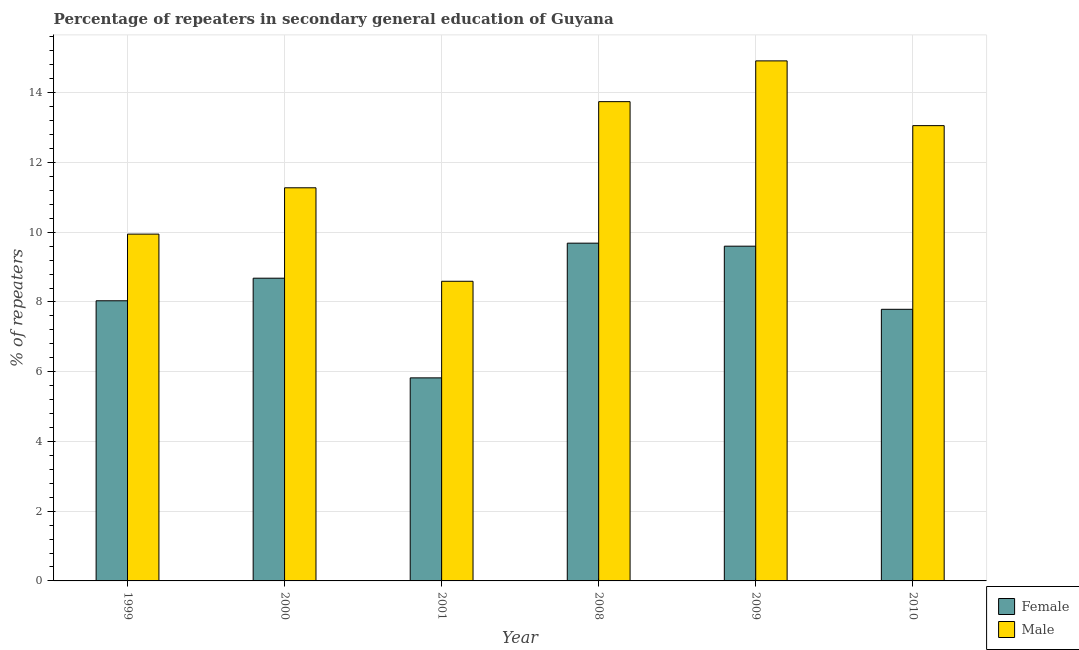How many different coloured bars are there?
Keep it short and to the point. 2. Are the number of bars on each tick of the X-axis equal?
Provide a short and direct response. Yes. How many bars are there on the 1st tick from the left?
Make the answer very short. 2. What is the label of the 2nd group of bars from the left?
Offer a terse response. 2000. In how many cases, is the number of bars for a given year not equal to the number of legend labels?
Make the answer very short. 0. What is the percentage of male repeaters in 1999?
Ensure brevity in your answer.  9.95. Across all years, what is the maximum percentage of male repeaters?
Offer a terse response. 14.91. Across all years, what is the minimum percentage of female repeaters?
Your answer should be very brief. 5.82. In which year was the percentage of male repeaters maximum?
Your answer should be compact. 2009. In which year was the percentage of male repeaters minimum?
Keep it short and to the point. 2001. What is the total percentage of female repeaters in the graph?
Your response must be concise. 49.61. What is the difference between the percentage of male repeaters in 1999 and that in 2009?
Offer a terse response. -4.97. What is the difference between the percentage of male repeaters in 2009 and the percentage of female repeaters in 2010?
Provide a short and direct response. 1.86. What is the average percentage of female repeaters per year?
Ensure brevity in your answer.  8.27. In the year 2001, what is the difference between the percentage of female repeaters and percentage of male repeaters?
Offer a terse response. 0. In how many years, is the percentage of female repeaters greater than 2.4 %?
Offer a very short reply. 6. What is the ratio of the percentage of female repeaters in 2000 to that in 2009?
Provide a succinct answer. 0.9. Is the percentage of male repeaters in 2000 less than that in 2010?
Provide a succinct answer. Yes. Is the difference between the percentage of male repeaters in 2000 and 2001 greater than the difference between the percentage of female repeaters in 2000 and 2001?
Ensure brevity in your answer.  No. What is the difference between the highest and the second highest percentage of female repeaters?
Keep it short and to the point. 0.09. What is the difference between the highest and the lowest percentage of male repeaters?
Your answer should be compact. 6.32. What does the 1st bar from the left in 2001 represents?
Offer a terse response. Female. How many bars are there?
Make the answer very short. 12. How many years are there in the graph?
Your answer should be very brief. 6. What is the difference between two consecutive major ticks on the Y-axis?
Ensure brevity in your answer.  2. Does the graph contain any zero values?
Offer a terse response. No. Does the graph contain grids?
Give a very brief answer. Yes. How are the legend labels stacked?
Provide a succinct answer. Vertical. What is the title of the graph?
Give a very brief answer. Percentage of repeaters in secondary general education of Guyana. What is the label or title of the Y-axis?
Provide a short and direct response. % of repeaters. What is the % of repeaters of Female in 1999?
Make the answer very short. 8.03. What is the % of repeaters of Male in 1999?
Keep it short and to the point. 9.95. What is the % of repeaters of Female in 2000?
Provide a succinct answer. 8.68. What is the % of repeaters in Male in 2000?
Provide a short and direct response. 11.27. What is the % of repeaters in Female in 2001?
Ensure brevity in your answer.  5.82. What is the % of repeaters of Male in 2001?
Your answer should be compact. 8.59. What is the % of repeaters in Female in 2008?
Provide a short and direct response. 9.69. What is the % of repeaters of Male in 2008?
Give a very brief answer. 13.74. What is the % of repeaters in Female in 2009?
Provide a succinct answer. 9.6. What is the % of repeaters in Male in 2009?
Your response must be concise. 14.91. What is the % of repeaters of Female in 2010?
Provide a short and direct response. 7.79. What is the % of repeaters in Male in 2010?
Provide a succinct answer. 13.06. Across all years, what is the maximum % of repeaters of Female?
Ensure brevity in your answer.  9.69. Across all years, what is the maximum % of repeaters in Male?
Give a very brief answer. 14.91. Across all years, what is the minimum % of repeaters in Female?
Your answer should be compact. 5.82. Across all years, what is the minimum % of repeaters in Male?
Your answer should be compact. 8.59. What is the total % of repeaters in Female in the graph?
Give a very brief answer. 49.61. What is the total % of repeaters of Male in the graph?
Offer a very short reply. 71.53. What is the difference between the % of repeaters in Female in 1999 and that in 2000?
Your answer should be compact. -0.65. What is the difference between the % of repeaters of Male in 1999 and that in 2000?
Your answer should be very brief. -1.33. What is the difference between the % of repeaters in Female in 1999 and that in 2001?
Make the answer very short. 2.21. What is the difference between the % of repeaters of Male in 1999 and that in 2001?
Offer a terse response. 1.35. What is the difference between the % of repeaters in Female in 1999 and that in 2008?
Offer a very short reply. -1.65. What is the difference between the % of repeaters of Male in 1999 and that in 2008?
Keep it short and to the point. -3.8. What is the difference between the % of repeaters of Female in 1999 and that in 2009?
Your response must be concise. -1.57. What is the difference between the % of repeaters in Male in 1999 and that in 2009?
Make the answer very short. -4.97. What is the difference between the % of repeaters in Female in 1999 and that in 2010?
Your answer should be very brief. 0.24. What is the difference between the % of repeaters of Male in 1999 and that in 2010?
Make the answer very short. -3.11. What is the difference between the % of repeaters in Female in 2000 and that in 2001?
Give a very brief answer. 2.86. What is the difference between the % of repeaters in Male in 2000 and that in 2001?
Offer a terse response. 2.68. What is the difference between the % of repeaters in Female in 2000 and that in 2008?
Provide a short and direct response. -1. What is the difference between the % of repeaters in Male in 2000 and that in 2008?
Keep it short and to the point. -2.47. What is the difference between the % of repeaters of Female in 2000 and that in 2009?
Offer a terse response. -0.92. What is the difference between the % of repeaters in Male in 2000 and that in 2009?
Your answer should be compact. -3.64. What is the difference between the % of repeaters of Female in 2000 and that in 2010?
Provide a short and direct response. 0.89. What is the difference between the % of repeaters in Male in 2000 and that in 2010?
Your answer should be very brief. -1.78. What is the difference between the % of repeaters of Female in 2001 and that in 2008?
Provide a short and direct response. -3.86. What is the difference between the % of repeaters in Male in 2001 and that in 2008?
Keep it short and to the point. -5.15. What is the difference between the % of repeaters in Female in 2001 and that in 2009?
Give a very brief answer. -3.78. What is the difference between the % of repeaters in Male in 2001 and that in 2009?
Offer a terse response. -6.32. What is the difference between the % of repeaters of Female in 2001 and that in 2010?
Your answer should be very brief. -1.97. What is the difference between the % of repeaters of Male in 2001 and that in 2010?
Offer a terse response. -4.46. What is the difference between the % of repeaters in Female in 2008 and that in 2009?
Provide a short and direct response. 0.09. What is the difference between the % of repeaters of Male in 2008 and that in 2009?
Give a very brief answer. -1.17. What is the difference between the % of repeaters in Female in 2008 and that in 2010?
Make the answer very short. 1.9. What is the difference between the % of repeaters in Male in 2008 and that in 2010?
Your answer should be compact. 0.69. What is the difference between the % of repeaters in Female in 2009 and that in 2010?
Your response must be concise. 1.81. What is the difference between the % of repeaters of Male in 2009 and that in 2010?
Your response must be concise. 1.86. What is the difference between the % of repeaters in Female in 1999 and the % of repeaters in Male in 2000?
Your answer should be very brief. -3.24. What is the difference between the % of repeaters of Female in 1999 and the % of repeaters of Male in 2001?
Offer a terse response. -0.56. What is the difference between the % of repeaters of Female in 1999 and the % of repeaters of Male in 2008?
Offer a very short reply. -5.71. What is the difference between the % of repeaters of Female in 1999 and the % of repeaters of Male in 2009?
Make the answer very short. -6.88. What is the difference between the % of repeaters in Female in 1999 and the % of repeaters in Male in 2010?
Give a very brief answer. -5.02. What is the difference between the % of repeaters of Female in 2000 and the % of repeaters of Male in 2001?
Provide a succinct answer. 0.09. What is the difference between the % of repeaters of Female in 2000 and the % of repeaters of Male in 2008?
Provide a succinct answer. -5.06. What is the difference between the % of repeaters of Female in 2000 and the % of repeaters of Male in 2009?
Make the answer very short. -6.23. What is the difference between the % of repeaters of Female in 2000 and the % of repeaters of Male in 2010?
Ensure brevity in your answer.  -4.38. What is the difference between the % of repeaters in Female in 2001 and the % of repeaters in Male in 2008?
Your response must be concise. -7.92. What is the difference between the % of repeaters of Female in 2001 and the % of repeaters of Male in 2009?
Provide a short and direct response. -9.09. What is the difference between the % of repeaters in Female in 2001 and the % of repeaters in Male in 2010?
Make the answer very short. -7.23. What is the difference between the % of repeaters of Female in 2008 and the % of repeaters of Male in 2009?
Offer a terse response. -5.23. What is the difference between the % of repeaters of Female in 2008 and the % of repeaters of Male in 2010?
Provide a succinct answer. -3.37. What is the difference between the % of repeaters in Female in 2009 and the % of repeaters in Male in 2010?
Make the answer very short. -3.46. What is the average % of repeaters of Female per year?
Your answer should be very brief. 8.27. What is the average % of repeaters in Male per year?
Your response must be concise. 11.92. In the year 1999, what is the difference between the % of repeaters in Female and % of repeaters in Male?
Your answer should be very brief. -1.91. In the year 2000, what is the difference between the % of repeaters in Female and % of repeaters in Male?
Your answer should be compact. -2.59. In the year 2001, what is the difference between the % of repeaters in Female and % of repeaters in Male?
Provide a short and direct response. -2.77. In the year 2008, what is the difference between the % of repeaters of Female and % of repeaters of Male?
Keep it short and to the point. -4.06. In the year 2009, what is the difference between the % of repeaters in Female and % of repeaters in Male?
Give a very brief answer. -5.31. In the year 2010, what is the difference between the % of repeaters in Female and % of repeaters in Male?
Make the answer very short. -5.27. What is the ratio of the % of repeaters in Female in 1999 to that in 2000?
Provide a succinct answer. 0.93. What is the ratio of the % of repeaters of Male in 1999 to that in 2000?
Your answer should be very brief. 0.88. What is the ratio of the % of repeaters of Female in 1999 to that in 2001?
Your response must be concise. 1.38. What is the ratio of the % of repeaters in Male in 1999 to that in 2001?
Your response must be concise. 1.16. What is the ratio of the % of repeaters of Female in 1999 to that in 2008?
Give a very brief answer. 0.83. What is the ratio of the % of repeaters in Male in 1999 to that in 2008?
Give a very brief answer. 0.72. What is the ratio of the % of repeaters in Female in 1999 to that in 2009?
Provide a succinct answer. 0.84. What is the ratio of the % of repeaters of Male in 1999 to that in 2009?
Make the answer very short. 0.67. What is the ratio of the % of repeaters in Female in 1999 to that in 2010?
Offer a very short reply. 1.03. What is the ratio of the % of repeaters in Male in 1999 to that in 2010?
Keep it short and to the point. 0.76. What is the ratio of the % of repeaters in Female in 2000 to that in 2001?
Your answer should be very brief. 1.49. What is the ratio of the % of repeaters of Male in 2000 to that in 2001?
Offer a terse response. 1.31. What is the ratio of the % of repeaters in Female in 2000 to that in 2008?
Ensure brevity in your answer.  0.9. What is the ratio of the % of repeaters of Male in 2000 to that in 2008?
Give a very brief answer. 0.82. What is the ratio of the % of repeaters in Female in 2000 to that in 2009?
Provide a short and direct response. 0.9. What is the ratio of the % of repeaters in Male in 2000 to that in 2009?
Your answer should be very brief. 0.76. What is the ratio of the % of repeaters of Female in 2000 to that in 2010?
Offer a very short reply. 1.11. What is the ratio of the % of repeaters in Male in 2000 to that in 2010?
Offer a terse response. 0.86. What is the ratio of the % of repeaters in Female in 2001 to that in 2008?
Your answer should be very brief. 0.6. What is the ratio of the % of repeaters of Male in 2001 to that in 2008?
Offer a very short reply. 0.63. What is the ratio of the % of repeaters in Female in 2001 to that in 2009?
Offer a terse response. 0.61. What is the ratio of the % of repeaters of Male in 2001 to that in 2009?
Offer a very short reply. 0.58. What is the ratio of the % of repeaters of Female in 2001 to that in 2010?
Provide a short and direct response. 0.75. What is the ratio of the % of repeaters in Male in 2001 to that in 2010?
Offer a very short reply. 0.66. What is the ratio of the % of repeaters in Female in 2008 to that in 2009?
Ensure brevity in your answer.  1.01. What is the ratio of the % of repeaters in Male in 2008 to that in 2009?
Your answer should be compact. 0.92. What is the ratio of the % of repeaters of Female in 2008 to that in 2010?
Make the answer very short. 1.24. What is the ratio of the % of repeaters of Male in 2008 to that in 2010?
Your answer should be compact. 1.05. What is the ratio of the % of repeaters in Female in 2009 to that in 2010?
Ensure brevity in your answer.  1.23. What is the ratio of the % of repeaters of Male in 2009 to that in 2010?
Offer a very short reply. 1.14. What is the difference between the highest and the second highest % of repeaters in Female?
Keep it short and to the point. 0.09. What is the difference between the highest and the second highest % of repeaters in Male?
Provide a short and direct response. 1.17. What is the difference between the highest and the lowest % of repeaters in Female?
Your response must be concise. 3.86. What is the difference between the highest and the lowest % of repeaters in Male?
Your response must be concise. 6.32. 